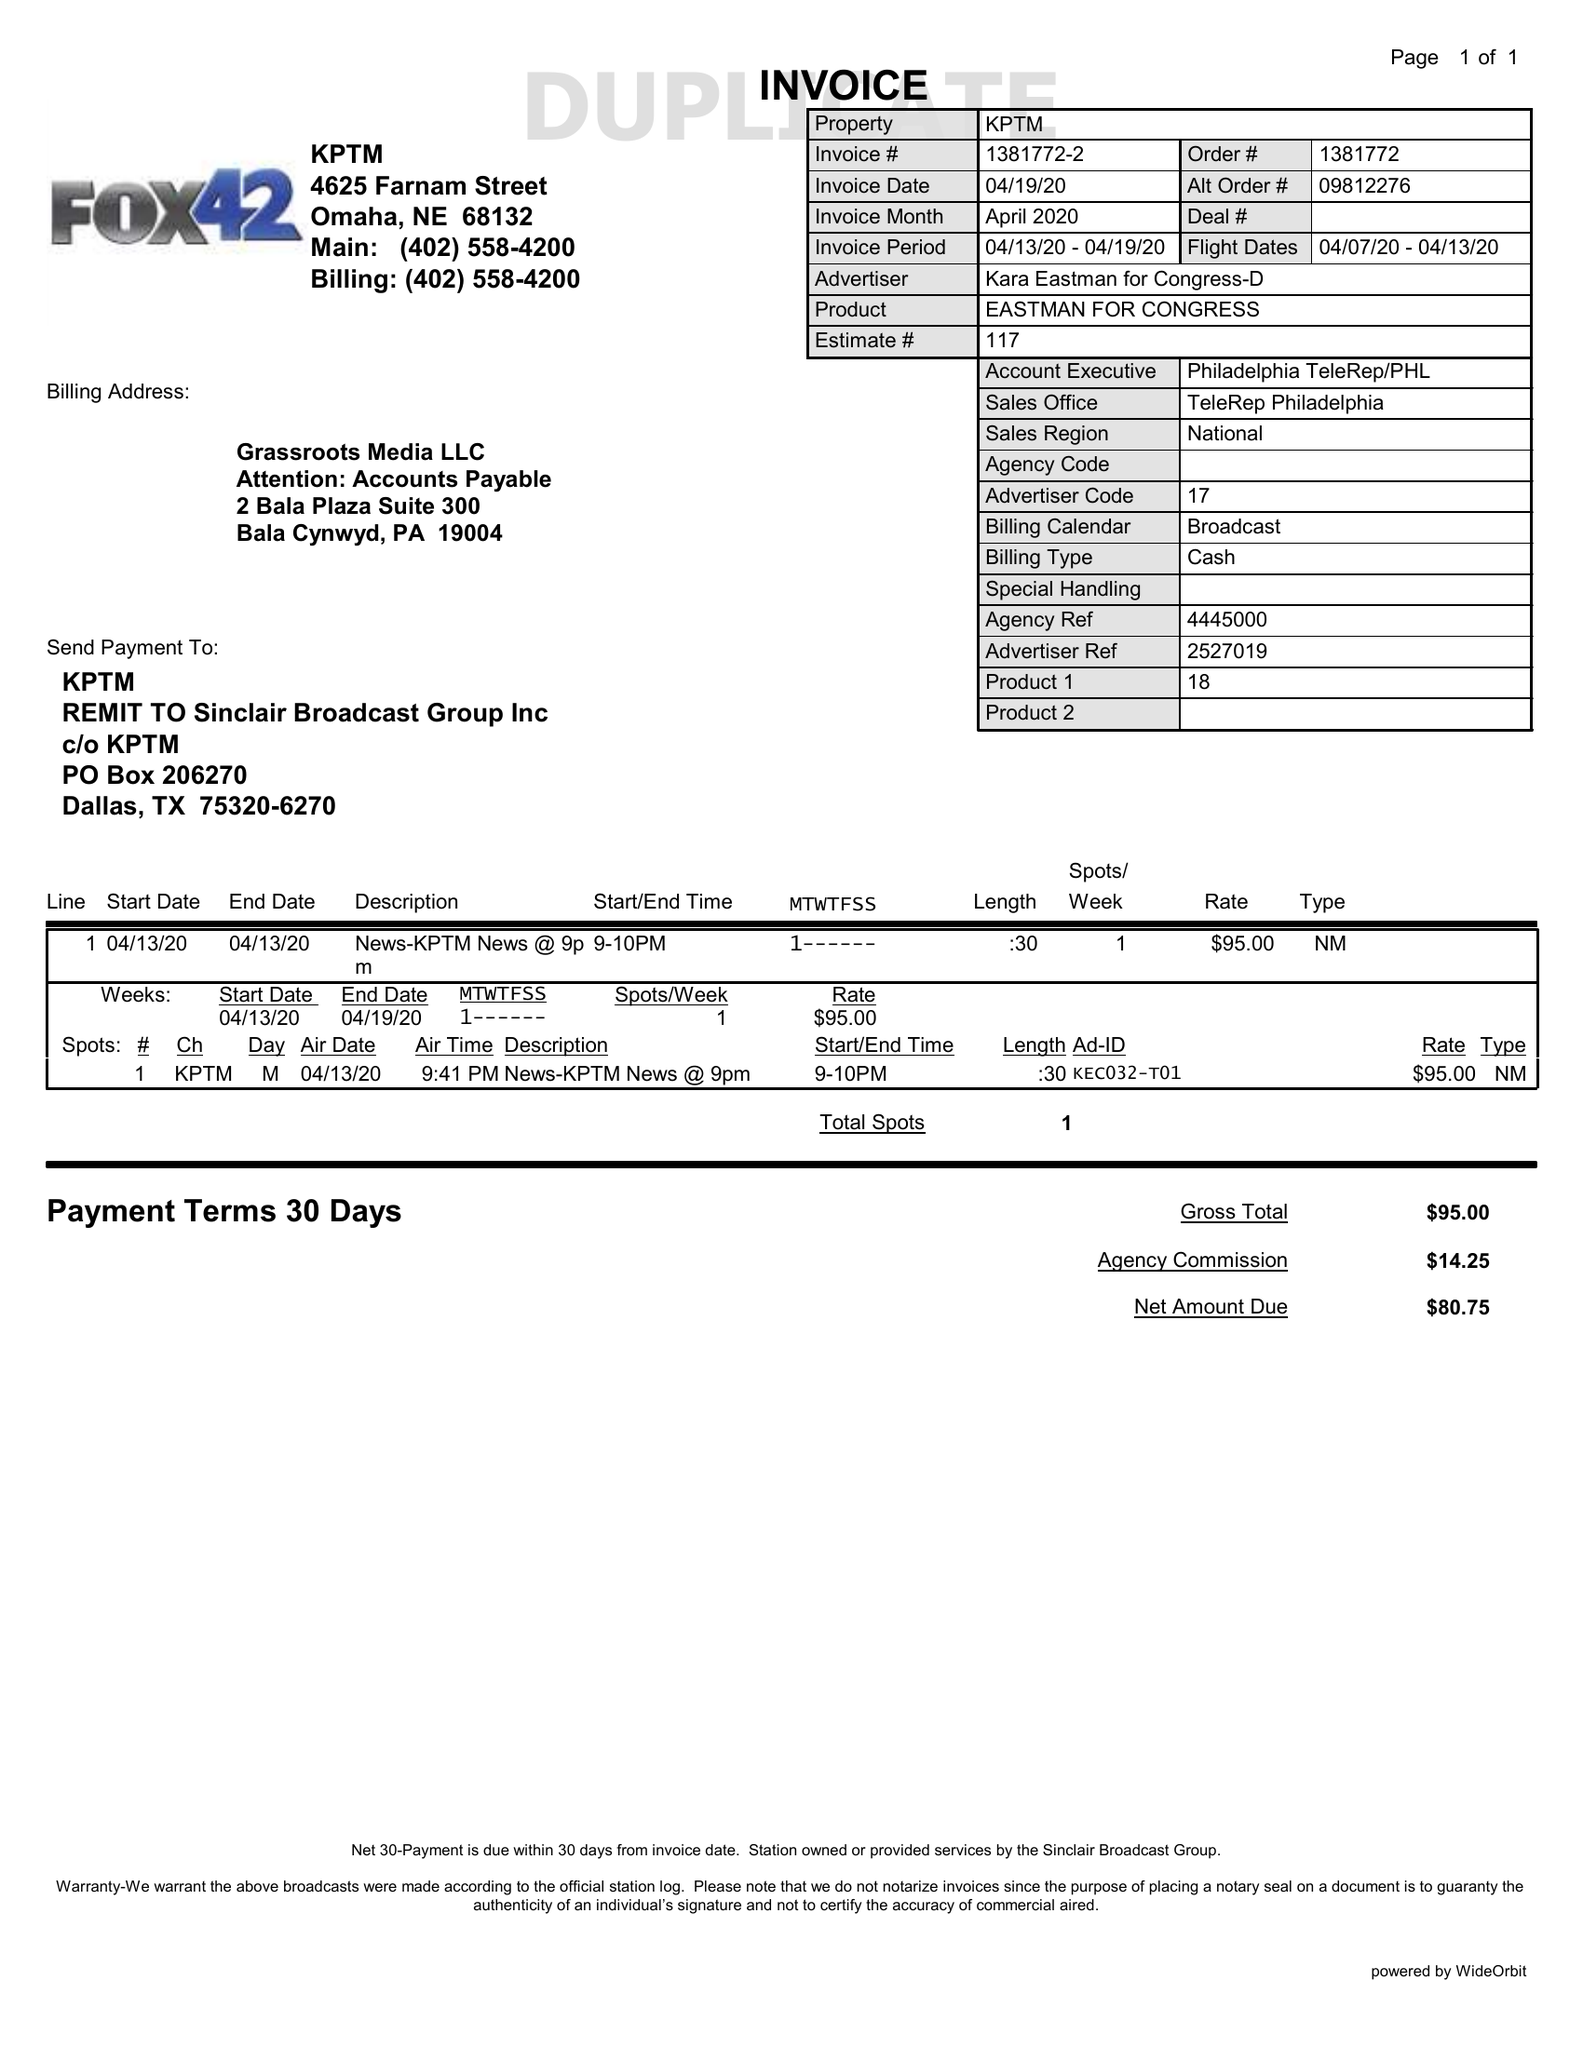What is the value for the gross_amount?
Answer the question using a single word or phrase. 95.00 